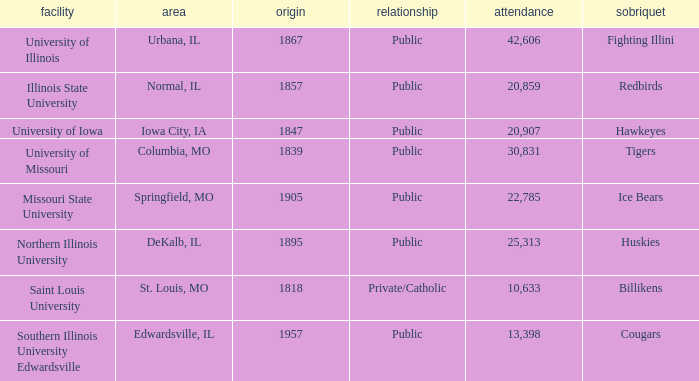What is the average enrollment of the Redbirds' school? 20859.0. 